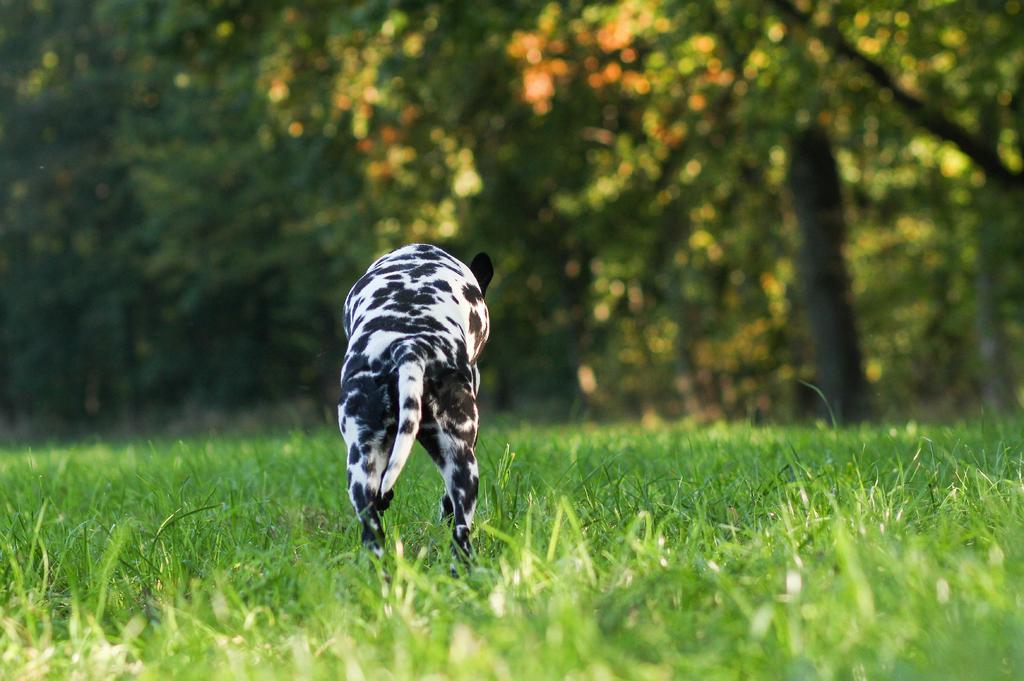Could you give a brief overview of what you see in this image? This image consists of an animal. At the bottom, there is green grass. In the background, there are trees. 